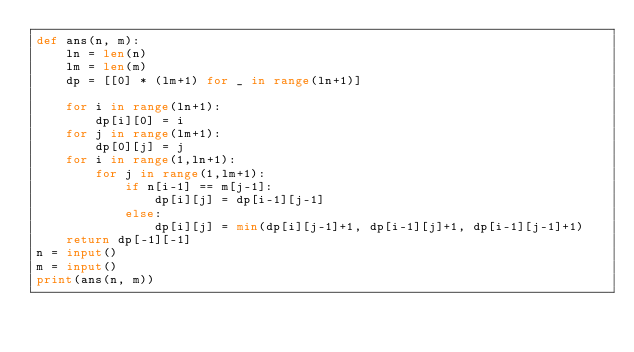<code> <loc_0><loc_0><loc_500><loc_500><_Python_>def ans(n, m):
    ln = len(n)
    lm = len(m)
    dp = [[0] * (lm+1) for _ in range(ln+1)]
    
    for i in range(ln+1):
        dp[i][0] = i
    for j in range(lm+1):
        dp[0][j] = j
    for i in range(1,ln+1):
        for j in range(1,lm+1):
            if n[i-1] == m[j-1]:
                dp[i][j] = dp[i-1][j-1]
            else:
                dp[i][j] = min(dp[i][j-1]+1, dp[i-1][j]+1, dp[i-1][j-1]+1)
    return dp[-1][-1]
n = input()
m = input()
print(ans(n, m))
</code> 